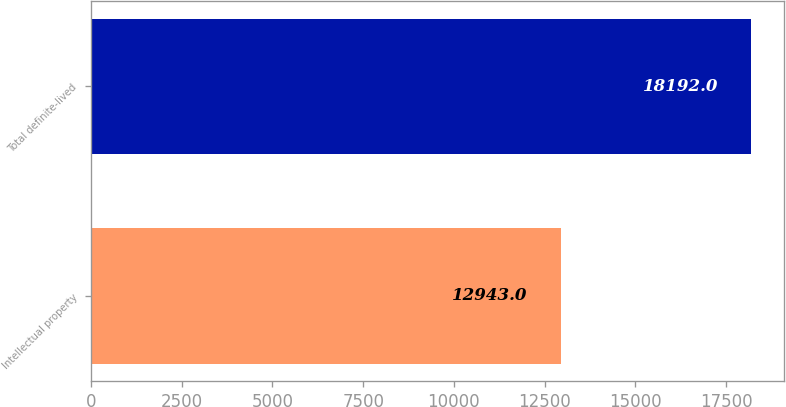Convert chart to OTSL. <chart><loc_0><loc_0><loc_500><loc_500><bar_chart><fcel>Intellectual property<fcel>Total definite-lived<nl><fcel>12943<fcel>18192<nl></chart> 